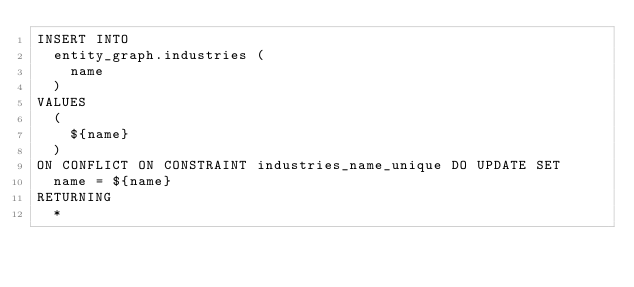Convert code to text. <code><loc_0><loc_0><loc_500><loc_500><_SQL_>INSERT INTO
  entity_graph.industries (
    name
  )
VALUES
  (
    ${name}
  )
ON CONFLICT ON CONSTRAINT industries_name_unique DO UPDATE SET
  name = ${name}
RETURNING
  *
</code> 